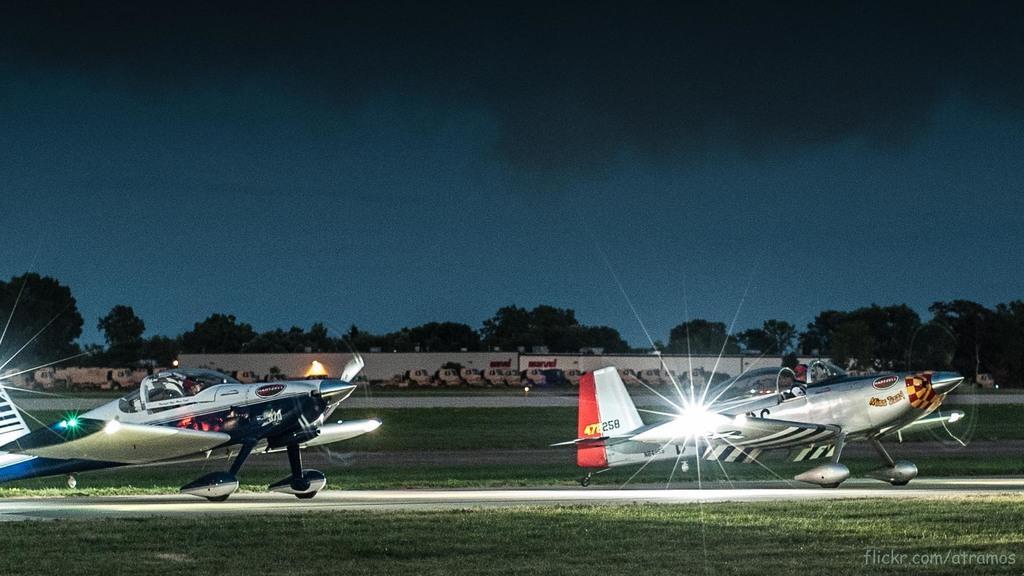In one or two sentences, can you explain what this image depicts? In this image, we can see two plane and two people are sitting inside the plane in the middle we can see some trees and in the background we can see the sky. 